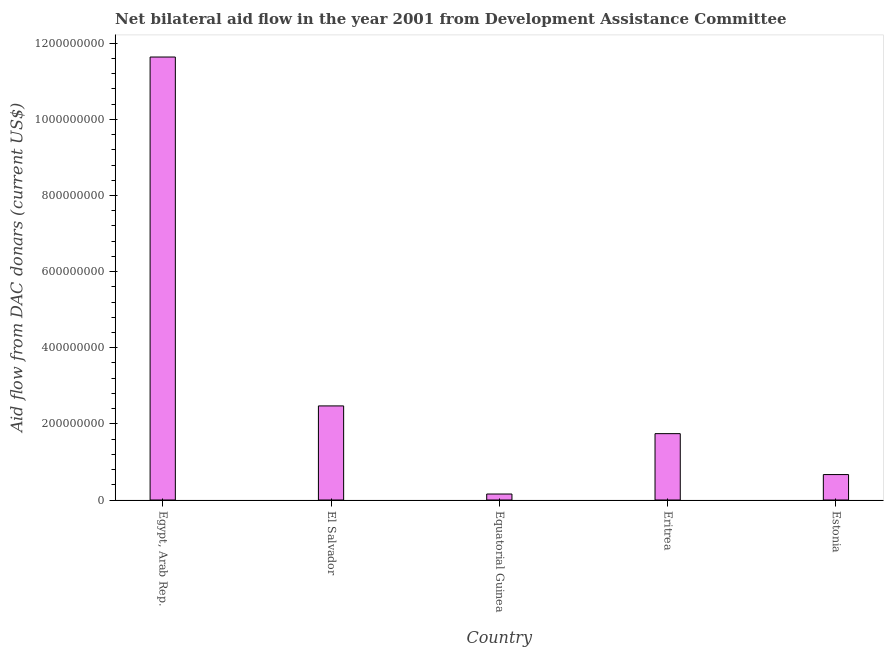What is the title of the graph?
Your answer should be very brief. Net bilateral aid flow in the year 2001 from Development Assistance Committee. What is the label or title of the X-axis?
Offer a terse response. Country. What is the label or title of the Y-axis?
Offer a terse response. Aid flow from DAC donars (current US$). What is the net bilateral aid flows from dac donors in Eritrea?
Offer a very short reply. 1.74e+08. Across all countries, what is the maximum net bilateral aid flows from dac donors?
Keep it short and to the point. 1.16e+09. Across all countries, what is the minimum net bilateral aid flows from dac donors?
Your response must be concise. 1.57e+07. In which country was the net bilateral aid flows from dac donors maximum?
Offer a terse response. Egypt, Arab Rep. In which country was the net bilateral aid flows from dac donors minimum?
Ensure brevity in your answer.  Equatorial Guinea. What is the sum of the net bilateral aid flows from dac donors?
Offer a very short reply. 1.67e+09. What is the difference between the net bilateral aid flows from dac donors in Equatorial Guinea and Estonia?
Your answer should be very brief. -5.11e+07. What is the average net bilateral aid flows from dac donors per country?
Your response must be concise. 3.34e+08. What is the median net bilateral aid flows from dac donors?
Offer a very short reply. 1.74e+08. What is the ratio of the net bilateral aid flows from dac donors in El Salvador to that in Estonia?
Make the answer very short. 3.7. What is the difference between the highest and the second highest net bilateral aid flows from dac donors?
Provide a succinct answer. 9.17e+08. What is the difference between the highest and the lowest net bilateral aid flows from dac donors?
Make the answer very short. 1.15e+09. Are all the bars in the graph horizontal?
Offer a very short reply. No. How many countries are there in the graph?
Your answer should be compact. 5. What is the difference between two consecutive major ticks on the Y-axis?
Offer a very short reply. 2.00e+08. Are the values on the major ticks of Y-axis written in scientific E-notation?
Your response must be concise. No. What is the Aid flow from DAC donars (current US$) in Egypt, Arab Rep.?
Provide a succinct answer. 1.16e+09. What is the Aid flow from DAC donars (current US$) in El Salvador?
Your answer should be compact. 2.47e+08. What is the Aid flow from DAC donars (current US$) in Equatorial Guinea?
Your answer should be compact. 1.57e+07. What is the Aid flow from DAC donars (current US$) in Eritrea?
Offer a terse response. 1.74e+08. What is the Aid flow from DAC donars (current US$) of Estonia?
Provide a short and direct response. 6.68e+07. What is the difference between the Aid flow from DAC donars (current US$) in Egypt, Arab Rep. and El Salvador?
Provide a short and direct response. 9.17e+08. What is the difference between the Aid flow from DAC donars (current US$) in Egypt, Arab Rep. and Equatorial Guinea?
Your response must be concise. 1.15e+09. What is the difference between the Aid flow from DAC donars (current US$) in Egypt, Arab Rep. and Eritrea?
Offer a very short reply. 9.90e+08. What is the difference between the Aid flow from DAC donars (current US$) in Egypt, Arab Rep. and Estonia?
Your answer should be compact. 1.10e+09. What is the difference between the Aid flow from DAC donars (current US$) in El Salvador and Equatorial Guinea?
Give a very brief answer. 2.31e+08. What is the difference between the Aid flow from DAC donars (current US$) in El Salvador and Eritrea?
Make the answer very short. 7.28e+07. What is the difference between the Aid flow from DAC donars (current US$) in El Salvador and Estonia?
Offer a very short reply. 1.80e+08. What is the difference between the Aid flow from DAC donars (current US$) in Equatorial Guinea and Eritrea?
Provide a succinct answer. -1.59e+08. What is the difference between the Aid flow from DAC donars (current US$) in Equatorial Guinea and Estonia?
Offer a very short reply. -5.11e+07. What is the difference between the Aid flow from DAC donars (current US$) in Eritrea and Estonia?
Keep it short and to the point. 1.08e+08. What is the ratio of the Aid flow from DAC donars (current US$) in Egypt, Arab Rep. to that in El Salvador?
Give a very brief answer. 4.71. What is the ratio of the Aid flow from DAC donars (current US$) in Egypt, Arab Rep. to that in Equatorial Guinea?
Your answer should be compact. 74.04. What is the ratio of the Aid flow from DAC donars (current US$) in Egypt, Arab Rep. to that in Eritrea?
Your answer should be compact. 6.67. What is the ratio of the Aid flow from DAC donars (current US$) in Egypt, Arab Rep. to that in Estonia?
Provide a succinct answer. 17.42. What is the ratio of the Aid flow from DAC donars (current US$) in El Salvador to that in Equatorial Guinea?
Your response must be concise. 15.72. What is the ratio of the Aid flow from DAC donars (current US$) in El Salvador to that in Eritrea?
Your response must be concise. 1.42. What is the ratio of the Aid flow from DAC donars (current US$) in El Salvador to that in Estonia?
Provide a short and direct response. 3.7. What is the ratio of the Aid flow from DAC donars (current US$) in Equatorial Guinea to that in Eritrea?
Keep it short and to the point. 0.09. What is the ratio of the Aid flow from DAC donars (current US$) in Equatorial Guinea to that in Estonia?
Provide a short and direct response. 0.23. What is the ratio of the Aid flow from DAC donars (current US$) in Eritrea to that in Estonia?
Your answer should be compact. 2.61. 